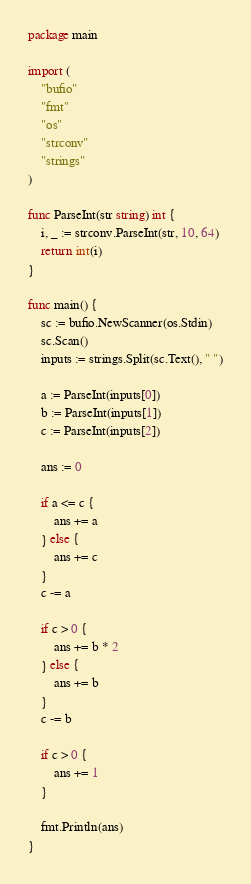<code> <loc_0><loc_0><loc_500><loc_500><_Go_>package main

import (
	"bufio"
	"fmt"
	"os"
	"strconv"
	"strings"
)

func ParseInt(str string) int {
	i, _ := strconv.ParseInt(str, 10, 64)
	return int(i)
}

func main() {
	sc := bufio.NewScanner(os.Stdin)
	sc.Scan()
	inputs := strings.Split(sc.Text(), " ")

	a := ParseInt(inputs[0])
	b := ParseInt(inputs[1])
	c := ParseInt(inputs[2])

	ans := 0

	if a <= c {
		ans += a
	} else {
		ans += c
	}
	c -= a

	if c > 0 {
		ans += b * 2
	} else {
		ans += b
	}
	c -= b

	if c > 0 {
		ans += 1
	}

	fmt.Println(ans)
}</code> 